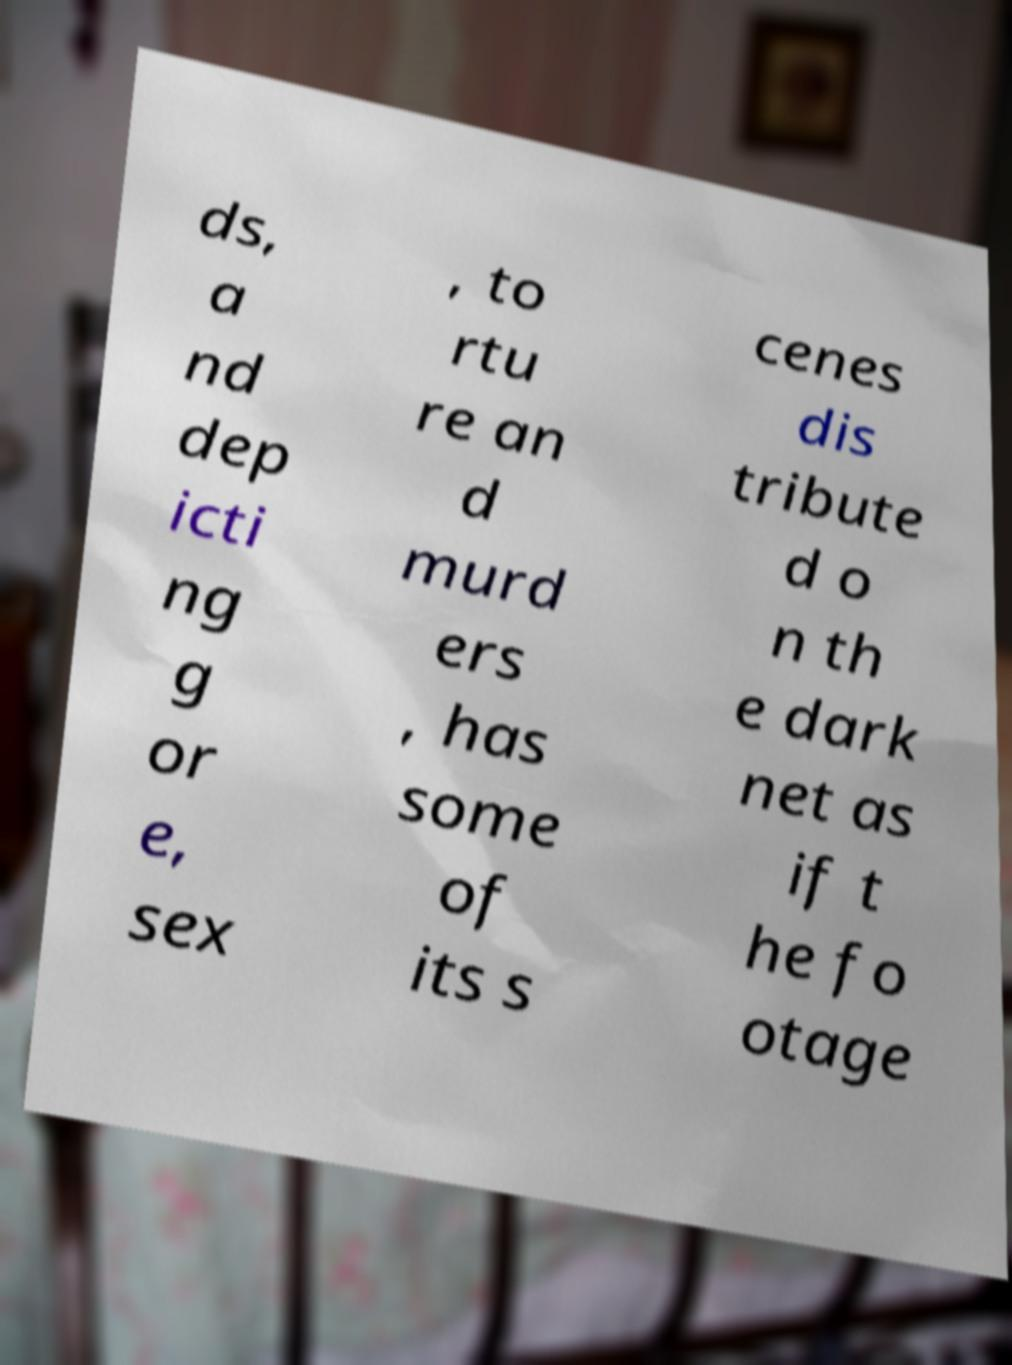For documentation purposes, I need the text within this image transcribed. Could you provide that? ds, a nd dep icti ng g or e, sex , to rtu re an d murd ers , has some of its s cenes dis tribute d o n th e dark net as if t he fo otage 